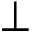Convert formula to latex. <formula><loc_0><loc_0><loc_500><loc_500>{ \perp }</formula> 